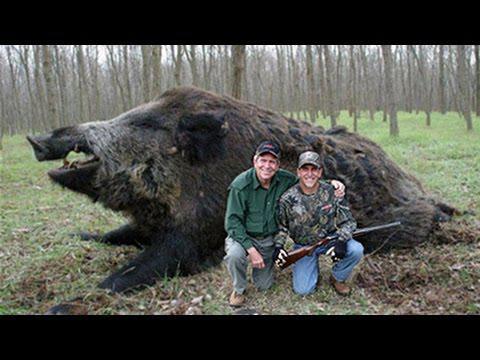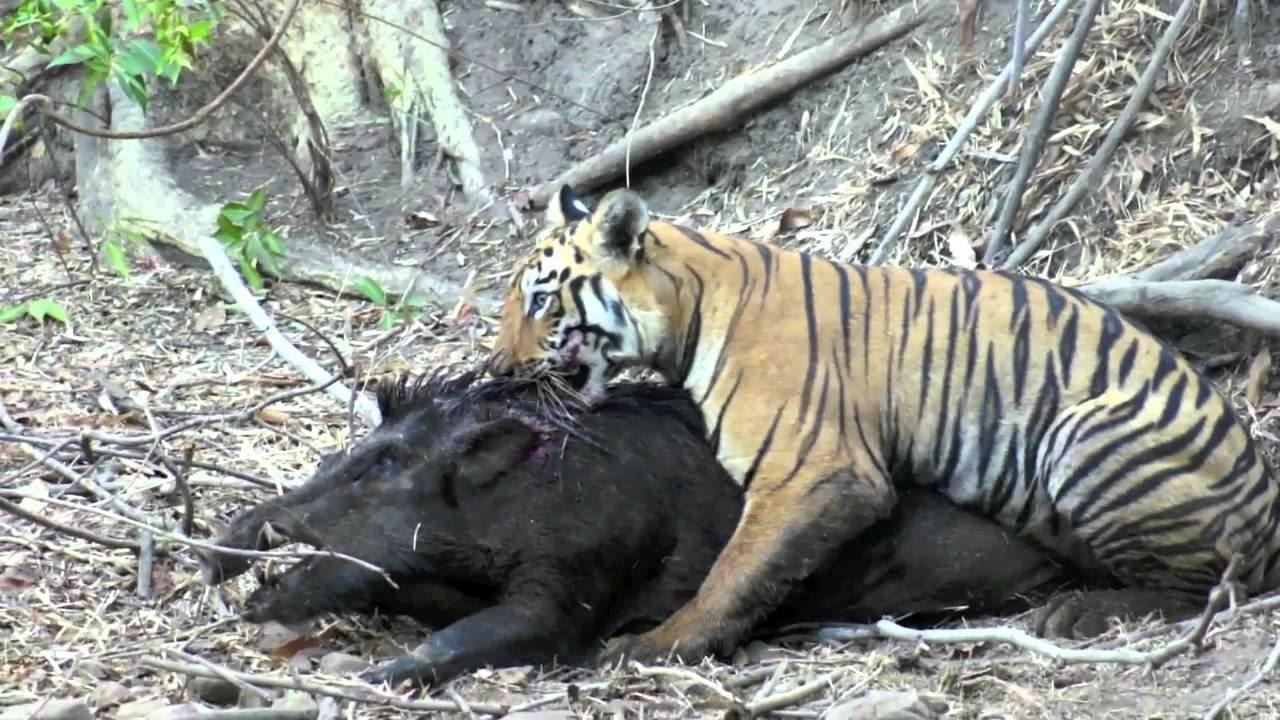The first image is the image on the left, the second image is the image on the right. Examine the images to the left and right. Is the description "One of the image features one man next to a dead wild boar." accurate? Answer yes or no. No. 